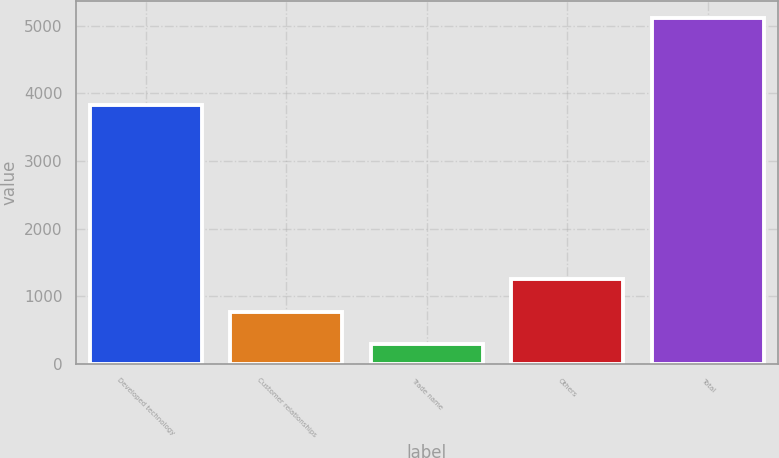<chart> <loc_0><loc_0><loc_500><loc_500><bar_chart><fcel>Developed technology<fcel>Customer relationships<fcel>Trade name<fcel>Others<fcel>Total<nl><fcel>3824<fcel>771.1<fcel>289<fcel>1253.2<fcel>5110<nl></chart> 